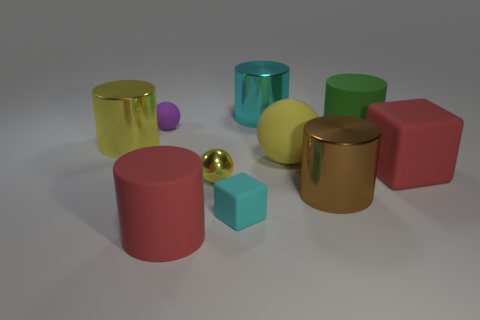Subtract all big red cylinders. How many cylinders are left? 4 Subtract 1 cylinders. How many cylinders are left? 4 Subtract all red cylinders. How many cylinders are left? 4 Subtract all blue cylinders. Subtract all cyan balls. How many cylinders are left? 5 Subtract all cubes. How many objects are left? 8 Subtract 0 green spheres. How many objects are left? 10 Subtract all purple things. Subtract all cyan rubber things. How many objects are left? 8 Add 7 big cyan metal things. How many big cyan metal things are left? 8 Add 3 large brown matte cylinders. How many large brown matte cylinders exist? 3 